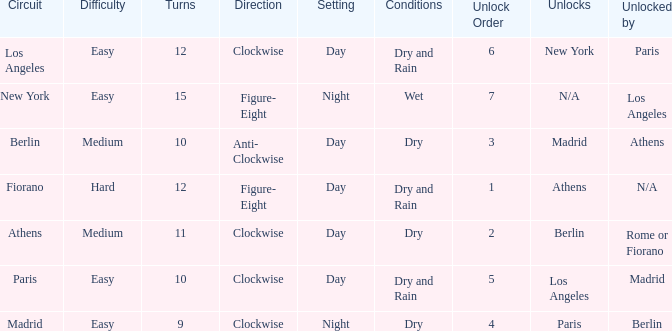What is the lowest unlock order for the athens circuit? 2.0. 